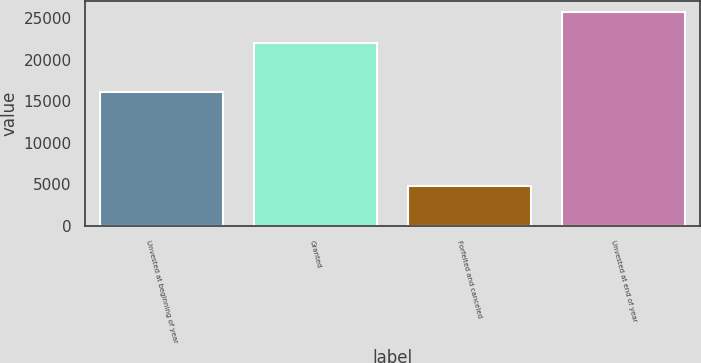Convert chart. <chart><loc_0><loc_0><loc_500><loc_500><bar_chart><fcel>Unvested at beginning of year<fcel>Granted<fcel>Forfeited and canceled<fcel>Unvested at end of year<nl><fcel>16176<fcel>22014<fcel>4850<fcel>25820<nl></chart> 